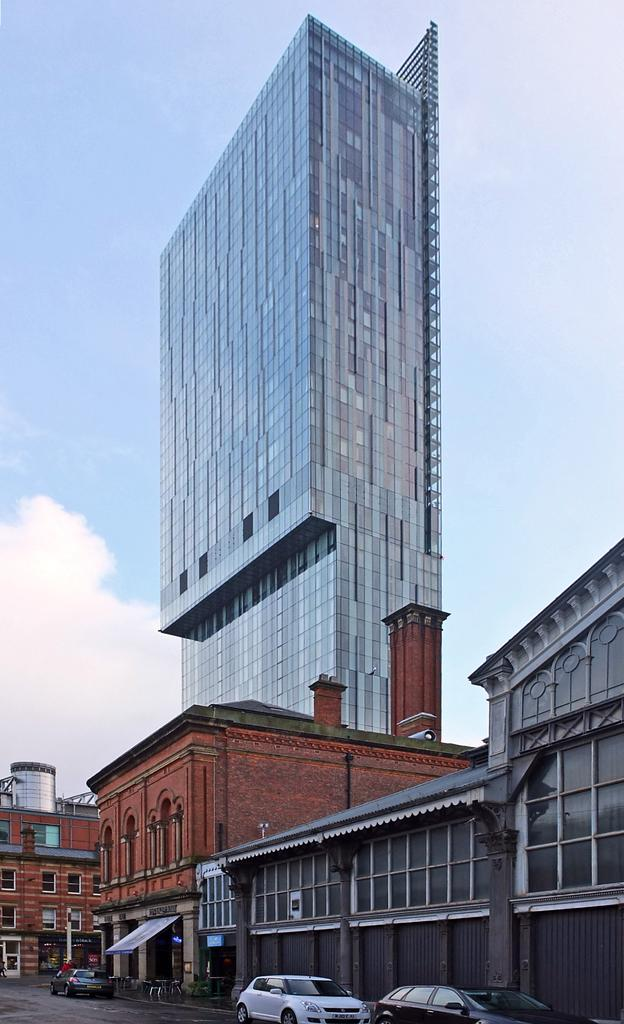What type of structures can be seen in the image? There are buildings in the image. Can you describe one of the buildings in the image? One of the buildings is brown. What else can be seen on the ground in the image? There are cars on the road. What is visible in the background of the image? The sky is visible in the background of the image. What can be observed in the sky? There are clouds in the sky. How many cherries are hanging from the eye of the building in the image? There are no cherries or eyes present on the buildings in the image. What type of trouble is the building experiencing in the image? There is no indication of any trouble or issues with the buildings in the image. 